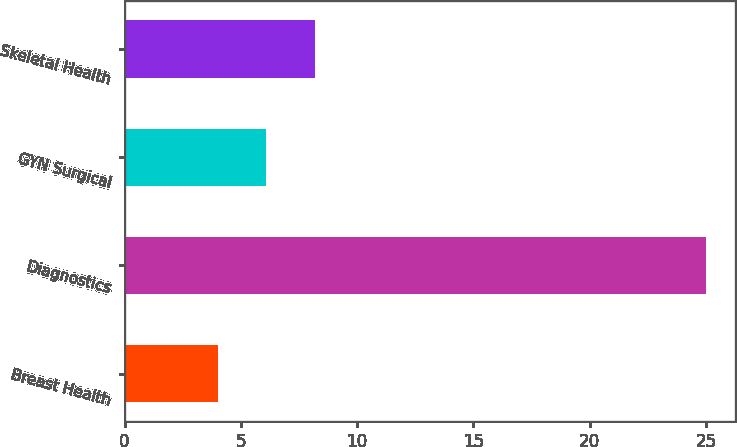Convert chart. <chart><loc_0><loc_0><loc_500><loc_500><bar_chart><fcel>Breast Health<fcel>Diagnostics<fcel>GYN Surgical<fcel>Skeletal Health<nl><fcel>4<fcel>25<fcel>6.1<fcel>8.2<nl></chart> 